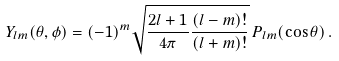<formula> <loc_0><loc_0><loc_500><loc_500>Y _ { l m } ( \theta , \phi ) = ( - 1 ) ^ { m } \sqrt { \frac { 2 l + 1 } { 4 \pi } \frac { ( l - m ) ! } { ( l + m ) ! } } \, P _ { l m } ( \cos \theta ) \, .</formula> 